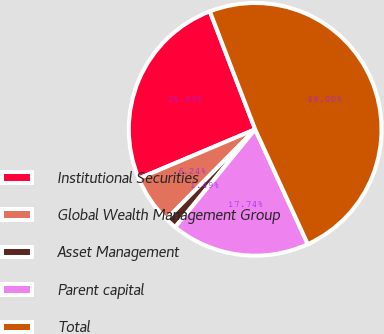<chart> <loc_0><loc_0><loc_500><loc_500><pie_chart><fcel>Institutional Securities<fcel>Global Wealth Management Group<fcel>Asset Management<fcel>Parent capital<fcel>Total<nl><fcel>25.53%<fcel>6.24%<fcel>1.49%<fcel>17.74%<fcel>49.0%<nl></chart> 